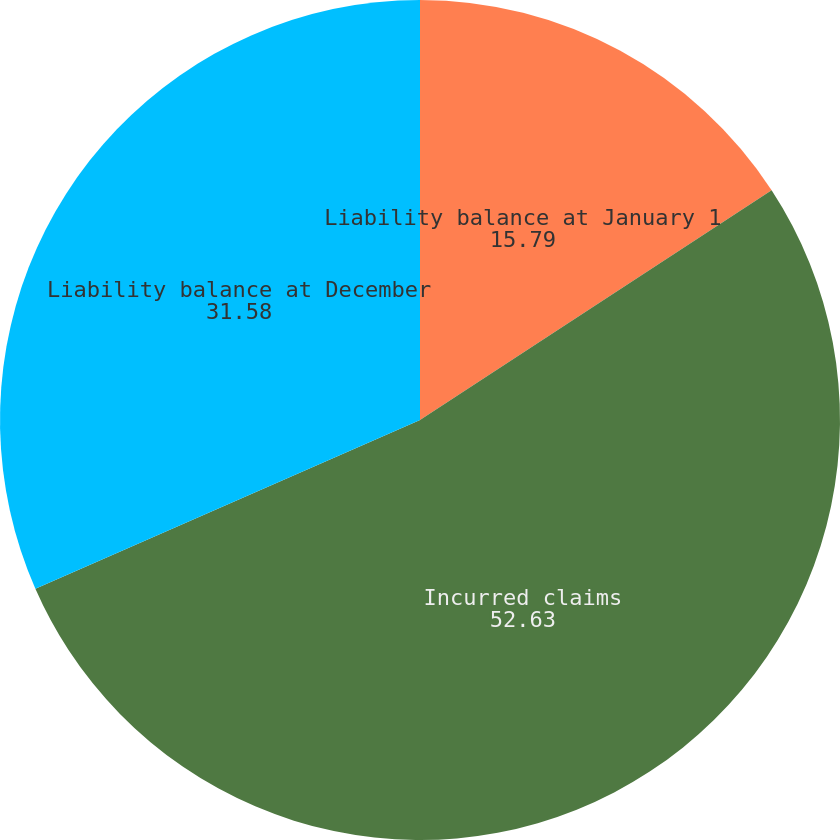Convert chart. <chart><loc_0><loc_0><loc_500><loc_500><pie_chart><fcel>Liability balance at January 1<fcel>Incurred claims<fcel>Liability balance at December<nl><fcel>15.79%<fcel>52.63%<fcel>31.58%<nl></chart> 